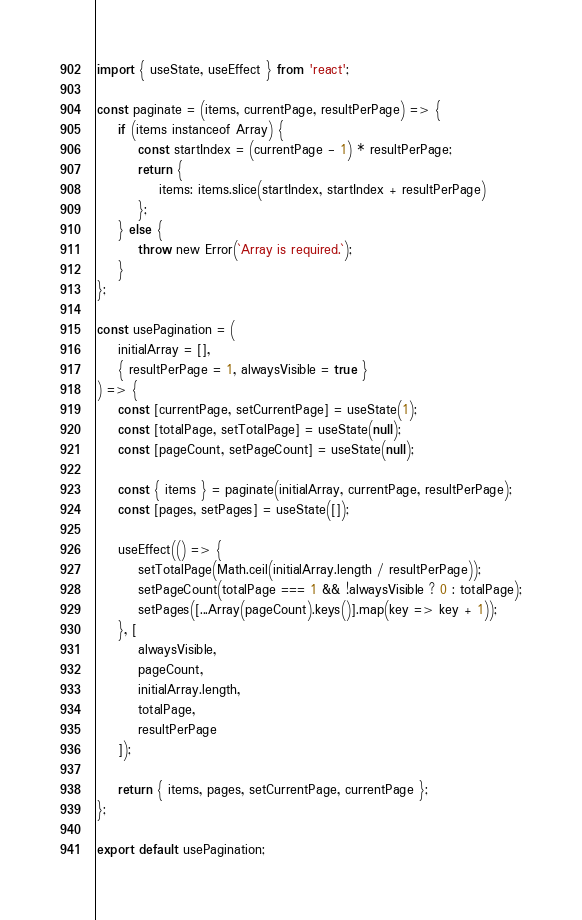<code> <loc_0><loc_0><loc_500><loc_500><_JavaScript_>import { useState, useEffect } from 'react';

const paginate = (items, currentPage, resultPerPage) => {
    if (items instanceof Array) {
        const startIndex = (currentPage - 1) * resultPerPage;
        return {
            items: items.slice(startIndex, startIndex + resultPerPage)
        };
    } else {
        throw new Error(`Array is required.`);
    }
};

const usePagination = (
    initialArray = [],
    { resultPerPage = 1, alwaysVisible = true }
) => {
    const [currentPage, setCurrentPage] = useState(1);
    const [totalPage, setTotalPage] = useState(null);
    const [pageCount, setPageCount] = useState(null);

    const { items } = paginate(initialArray, currentPage, resultPerPage);
    const [pages, setPages] = useState([]);

    useEffect(() => {
        setTotalPage(Math.ceil(initialArray.length / resultPerPage));
        setPageCount(totalPage === 1 && !alwaysVisible ? 0 : totalPage);
        setPages([...Array(pageCount).keys()].map(key => key + 1));
    }, [
        alwaysVisible,
        pageCount,
        initialArray.length,
        totalPage,
        resultPerPage
    ]);

    return { items, pages, setCurrentPage, currentPage };
};

export default usePagination;
</code> 